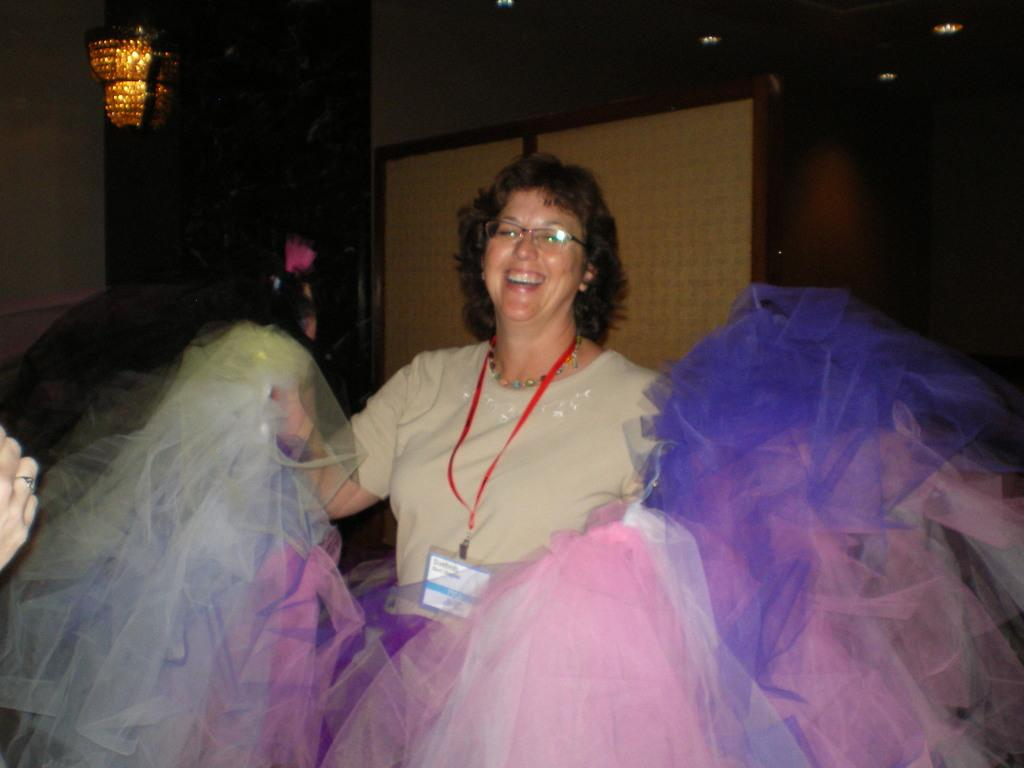What can be seen in the image? There is a person in the image. Can you describe the person's appearance? The person is wearing clothes and spectacles. What is visible in the top left of the image? There is a light in the top left of the image. What else can be seen on the left side of the image? There is a hand on the left side of the image. What type of muscle is being exercised by the person in the image? There is no indication of the person exercising any muscles in the image. 